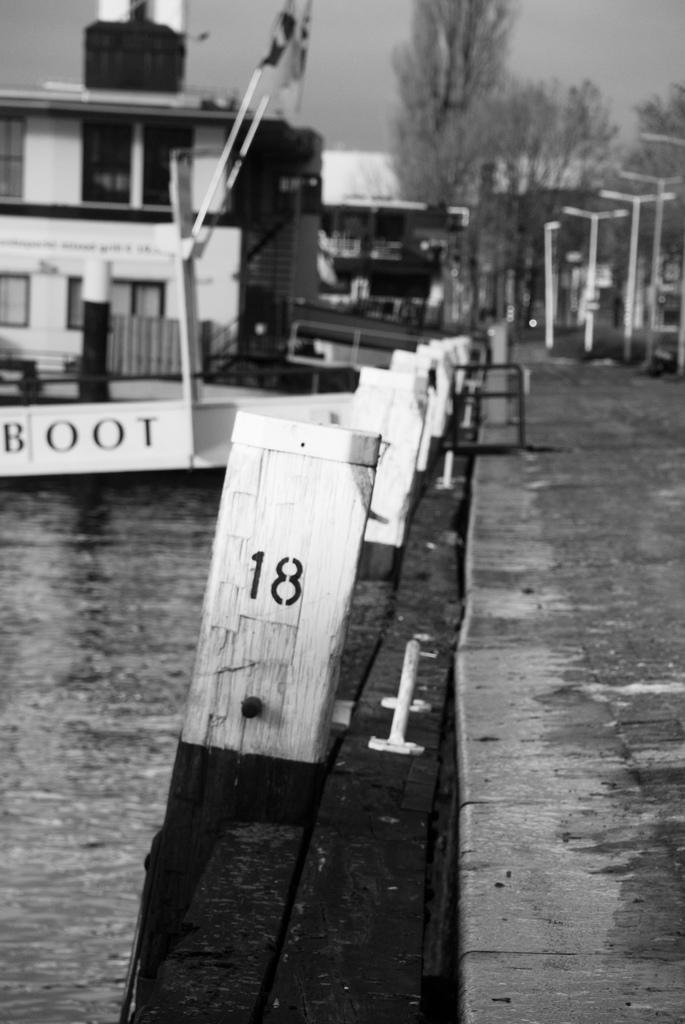What is the main subject of the image? The main subject of the image is a boat. Where is the boat located? The boat is in a water body. What else can be seen in the image besides the boat? There are poles, a group of trees, a building, and the sky visible in the image. What type of cheese is hanging from the poles in the image? There is no cheese present in the image; the poles are not related to cheese. 